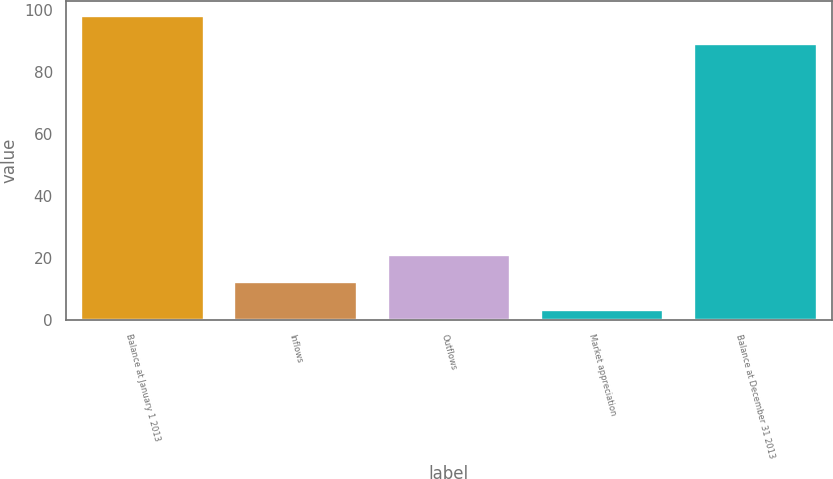Convert chart to OTSL. <chart><loc_0><loc_0><loc_500><loc_500><bar_chart><fcel>Balance at January 1 2013<fcel>Inflows<fcel>Outflows<fcel>Market appreciation<fcel>Balance at December 31 2013<nl><fcel>97.97<fcel>12.17<fcel>21.04<fcel>3.3<fcel>89.1<nl></chart> 